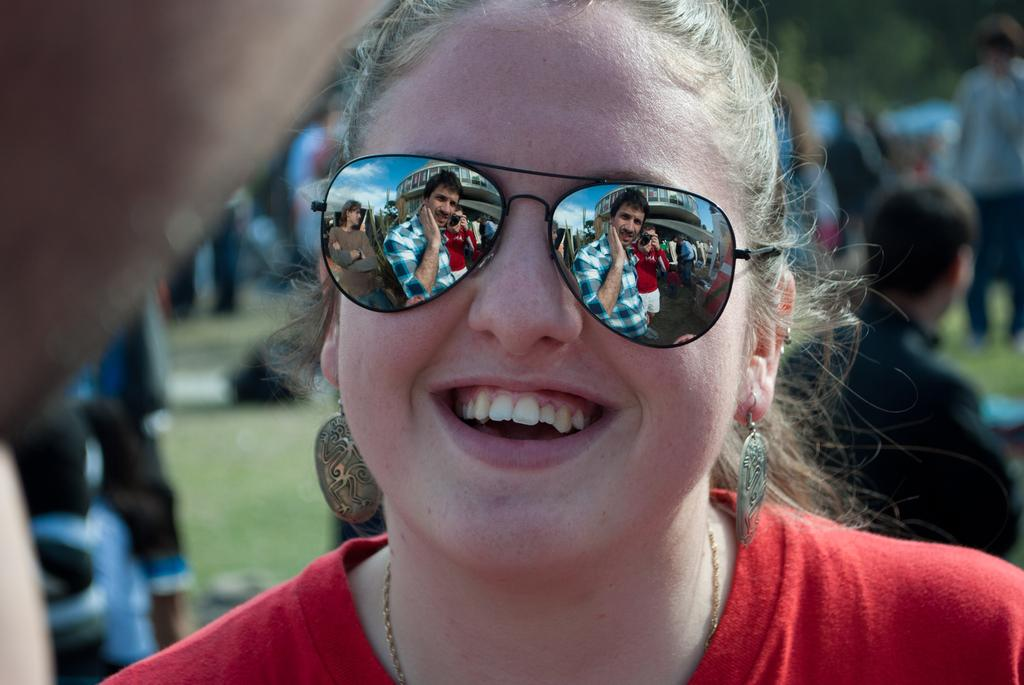Who is the main subject in the image? There is a woman in the image. What is the woman wearing on her face? The woman is wearing goggles. Where is the woman located in the image? The woman is in the middle of the image. Can you describe the background of the image? There are other persons in the background of the image. What can be seen in the woman's goggles? There is a reflection of some persons in the woman's goggles. What type of riddle can be solved by looking at the woman's goggles? There is no riddle present in the image, and therefore no such activity can be observed. 